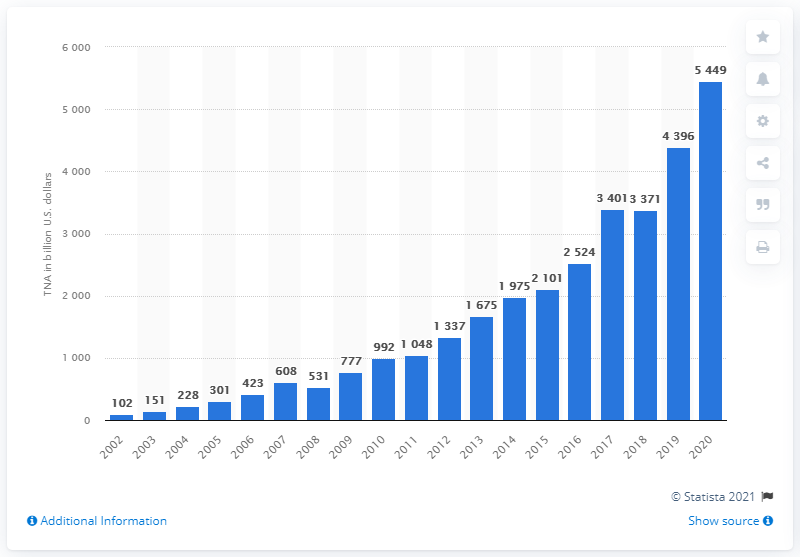Indicate a few pertinent items in this graphic. In 2020, the total net assets of U.S. ETFs were approximately 5449 in dollars. 